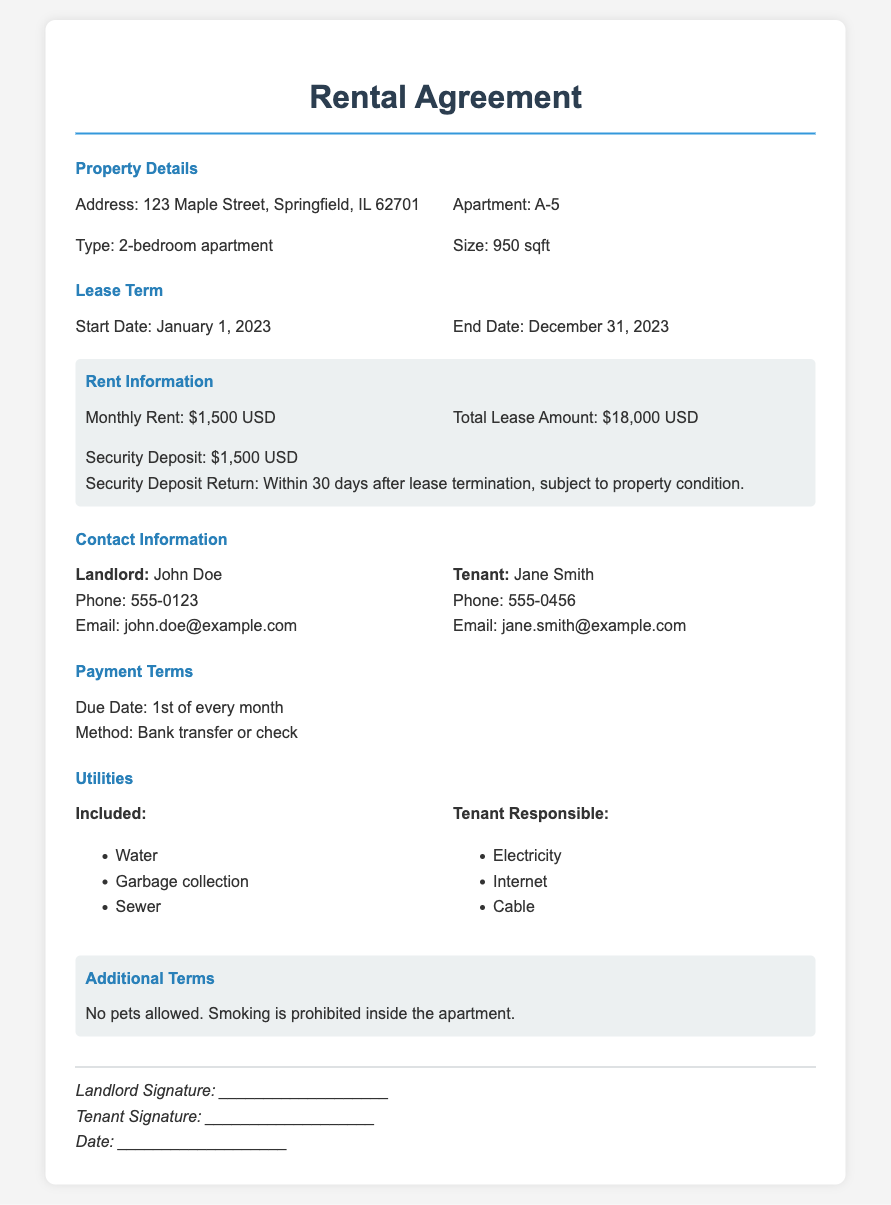What is the address of the property? The address is explicitly stated in the Property Details section and is "123 Maple Street, Springfield, IL 62701."
Answer: 123 Maple Street, Springfield, IL 62701 What is the monthly rent amount? The monthly rent is clearly listed in the Rent Information section as "$1,500 USD."
Answer: $1,500 USD What is the security deposit? The security deposit is outlined in the Rent Information section as "$1,500 USD."
Answer: $1,500 USD When does the lease start and end? The lease term is stated in the Lease Term section, specifying the start and end dates.
Answer: January 1, 2023 to December 31, 2023 How much is the total lease amount? The total lease amount is specified in the Rent Information section as "$18,000 USD."
Answer: $18,000 USD What utilities are included? The included utilities are listed in the Utilities section, specifically naming water, garbage collection, and sewer.
Answer: Water, Garbage collection, Sewer What date is the rent due? The due date for rent is provided in the Payment Terms section as the "1st of every month."
Answer: 1st of every month Who is the landlord? The landlord's name is clearly stated in the Contact Information section as "John Doe."
Answer: John Doe What are the additional terms regarding pets and smoking? The additional terms regarding pets and smoking are detailed in the Additional Terms section of the document.
Answer: No pets allowed. Smoking is prohibited inside the apartment 